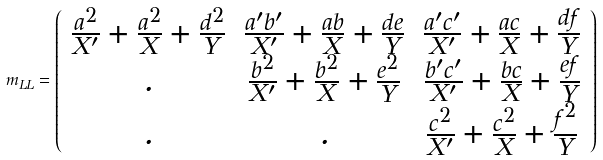<formula> <loc_0><loc_0><loc_500><loc_500>m _ { L L } = \left ( \begin{array} { c c c } { { \frac { a ^ { 2 } } { X ^ { \prime } } + \frac { a ^ { 2 } } { X } + \frac { d ^ { 2 } } { Y } } } & { { \frac { a ^ { \prime } b ^ { \prime } } { X ^ { \prime } } + \frac { a b } { X } + \frac { d e } { Y } } } & { { \frac { a ^ { \prime } c ^ { \prime } } { X ^ { \prime } } + \frac { a c } { X } + \frac { d f } { Y } } } \\ { . } & { { \frac { b ^ { 2 } } { X ^ { \prime } } + \frac { b ^ { 2 } } { X } + \frac { e ^ { 2 } } { Y } } } & { { \frac { b ^ { \prime } c ^ { \prime } } { X ^ { \prime } } + \frac { b c } { X } + \frac { e f } { Y } } } \\ { . } & { . } & { { \frac { c ^ { 2 } } { X ^ { \prime } } + \frac { c ^ { 2 } } { X } + \frac { f ^ { 2 } } { Y } } } \end{array} \right )</formula> 